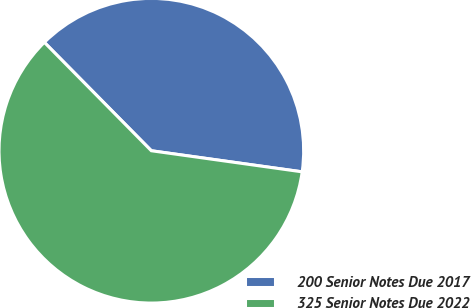Convert chart to OTSL. <chart><loc_0><loc_0><loc_500><loc_500><pie_chart><fcel>200 Senior Notes Due 2017<fcel>325 Senior Notes Due 2022<nl><fcel>39.61%<fcel>60.39%<nl></chart> 